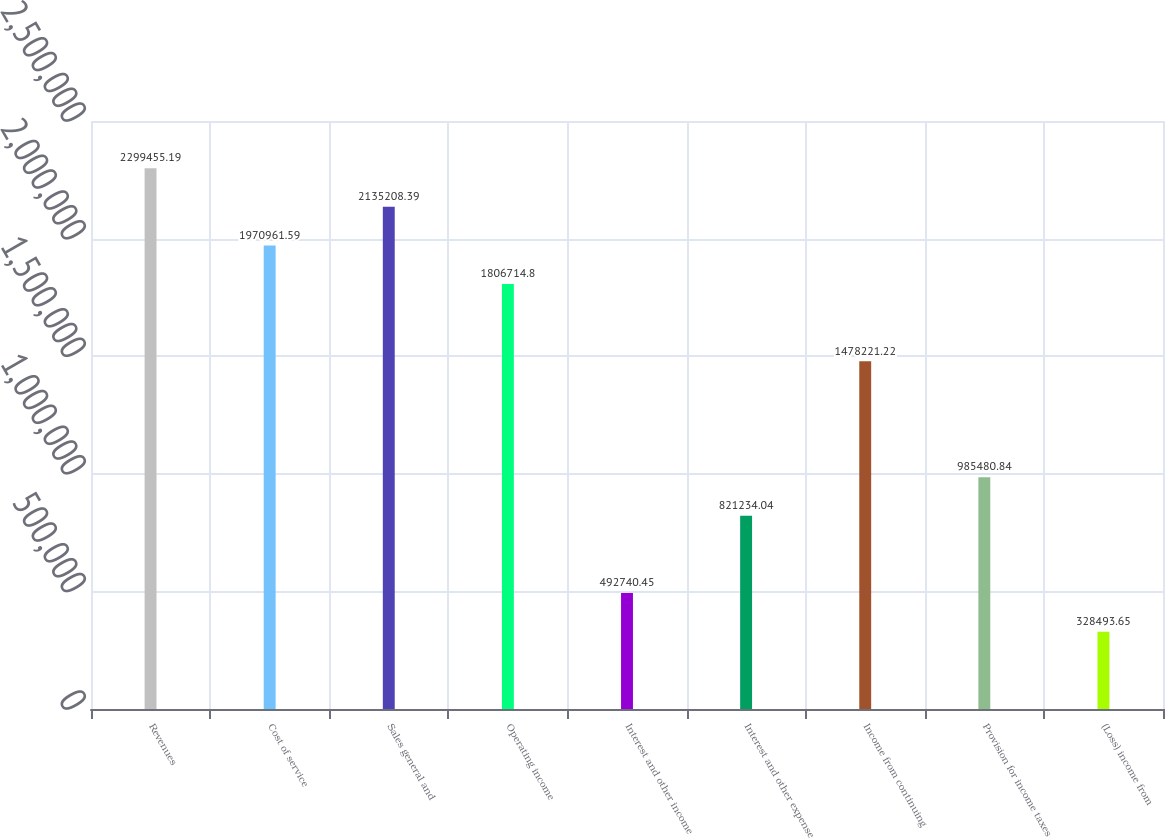<chart> <loc_0><loc_0><loc_500><loc_500><bar_chart><fcel>Revenues<fcel>Cost of service<fcel>Sales general and<fcel>Operating income<fcel>Interest and other income<fcel>Interest and other expense<fcel>Income from continuing<fcel>Provision for income taxes<fcel>(Loss) income from<nl><fcel>2.29946e+06<fcel>1.97096e+06<fcel>2.13521e+06<fcel>1.80671e+06<fcel>492740<fcel>821234<fcel>1.47822e+06<fcel>985481<fcel>328494<nl></chart> 